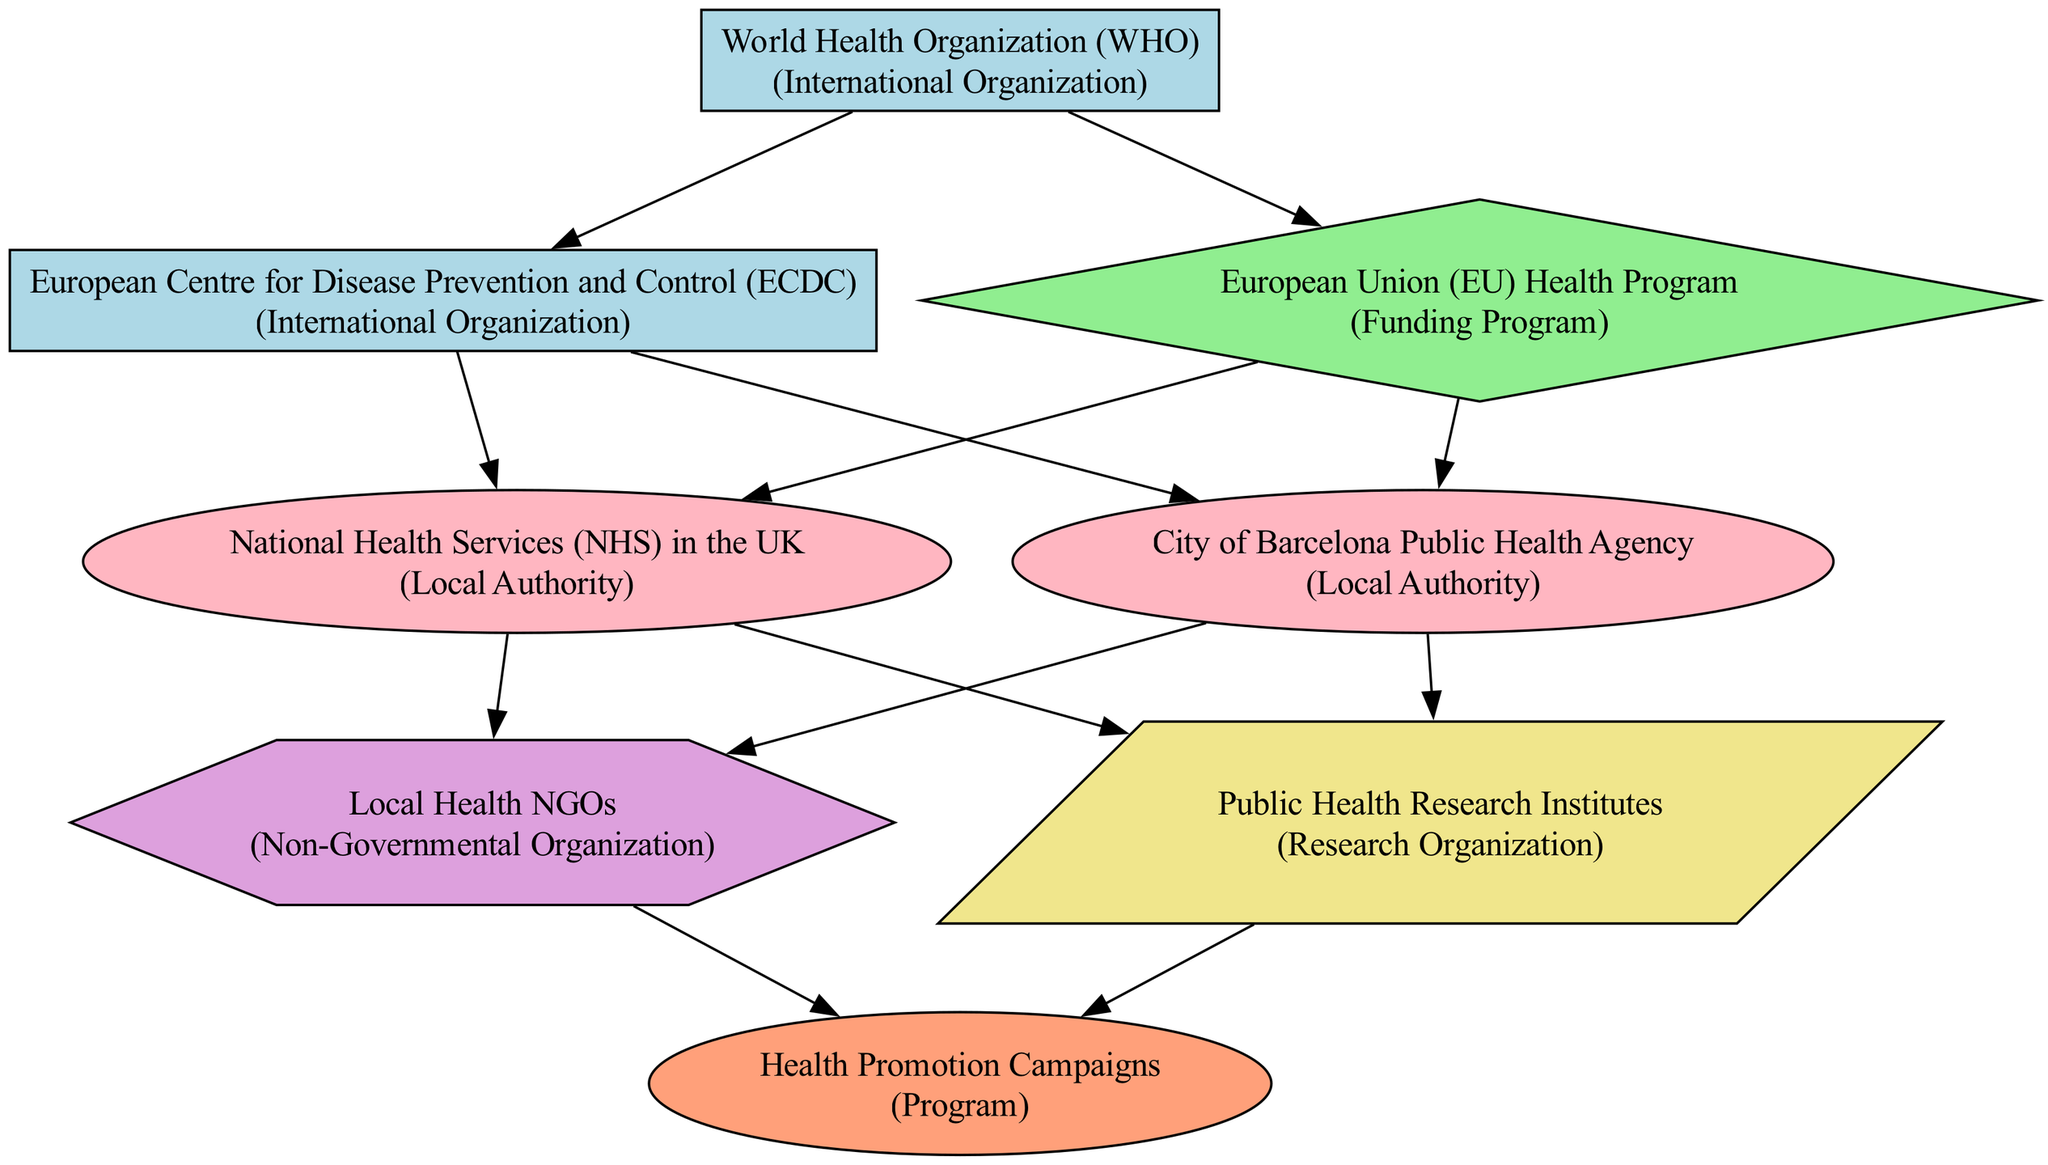What is the source of funding for the City of Barcelona Public Health Agency? The diagram indicates that the City of Barcelona Public Health Agency receives funding from both the World Health Organization and the European Union Health Program.
Answer: World Health Organization, European Union Health Program How many local authorities are represented in the diagram? The diagram features two local authorities: the National Health Services in the UK and the City of Barcelona Public Health Agency, which are both shown as local nodes.
Answer: 2 Which international organization is directly connected to the European Centre for Disease Prevention and Control? From the diagram, it is clear that the World Health Organization is directly linked to the European Centre for Disease Prevention and Control, indicating its supervisory role.
Answer: World Health Organization What type of relationship exists between Local Health NGOs and Health Promotion Campaigns? The diagram illustrates a flow from Local Health NGOs to Health Promotion Campaigns, indicating that Local Health NGOs fund these initiatives.
Answer: Funding Which two entities work with Public Health Research Institutes? The diagram shows connections from both the National Health Services in the UK and the City of Barcelona Public Health Agency to Public Health Research Institutes, indicating they both collaborate with research institutes for public health initiatives.
Answer: National Health Services in the UK, City of Barcelona Public Health Agency How many edges are there connecting the European Union Health Program to local authorities? Observing the diagram reveals that there are two edges leading from the European Union Health Program to local authorities, specifically connecting to both the National Health Services in the UK and the City of Barcelona Public Health Agency.
Answer: 2 What type of organization is the European Centre for Disease Prevention and Control? The diagram categorizes the European Centre for Disease Prevention and Control as an International Organization, establishing its role within the public health system.
Answer: International Organization Which program is promoted by both Local Health NGOs and Public Health Research Institutes? The connection in the diagram indicates that both Local Health NGOs and Public Health Research Institutes are linked to Health Promotion Campaigns, suggesting that both organizations promote these initiatives.
Answer: Health Promotion Campaigns 